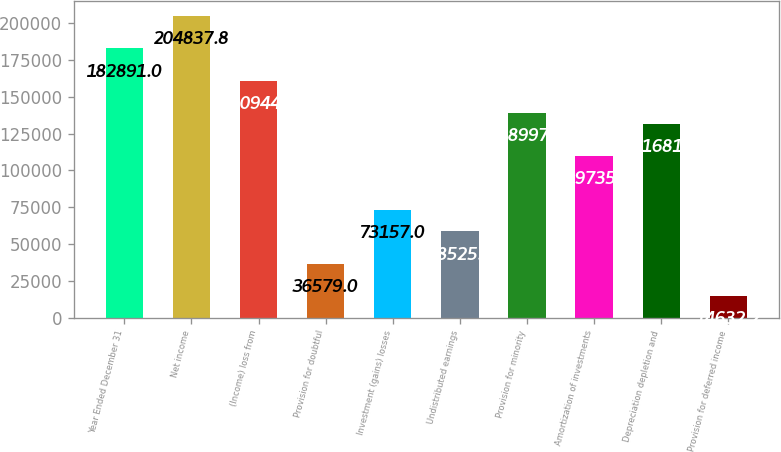<chart> <loc_0><loc_0><loc_500><loc_500><bar_chart><fcel>Year Ended December 31<fcel>Net income<fcel>(Income) loss from<fcel>Provision for doubtful<fcel>Investment (gains) losses<fcel>Undistributed earnings<fcel>Provision for minority<fcel>Amortization of investments<fcel>Depreciation depletion and<fcel>Provision for deferred income<nl><fcel>182891<fcel>204838<fcel>160944<fcel>36579<fcel>73157<fcel>58525.8<fcel>138997<fcel>109735<fcel>131682<fcel>14632.2<nl></chart> 